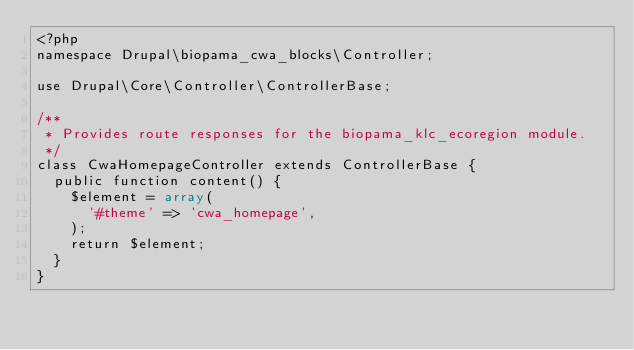<code> <loc_0><loc_0><loc_500><loc_500><_PHP_><?php
namespace Drupal\biopama_cwa_blocks\Controller;

use Drupal\Core\Controller\ControllerBase;

/**
 * Provides route responses for the biopama_klc_ecoregion module.
 */
class CwaHomepageController extends ControllerBase {
  public function content() {
    $element = array(
	  '#theme' => 'cwa_homepage',
    );
    return $element;
  }
}</code> 